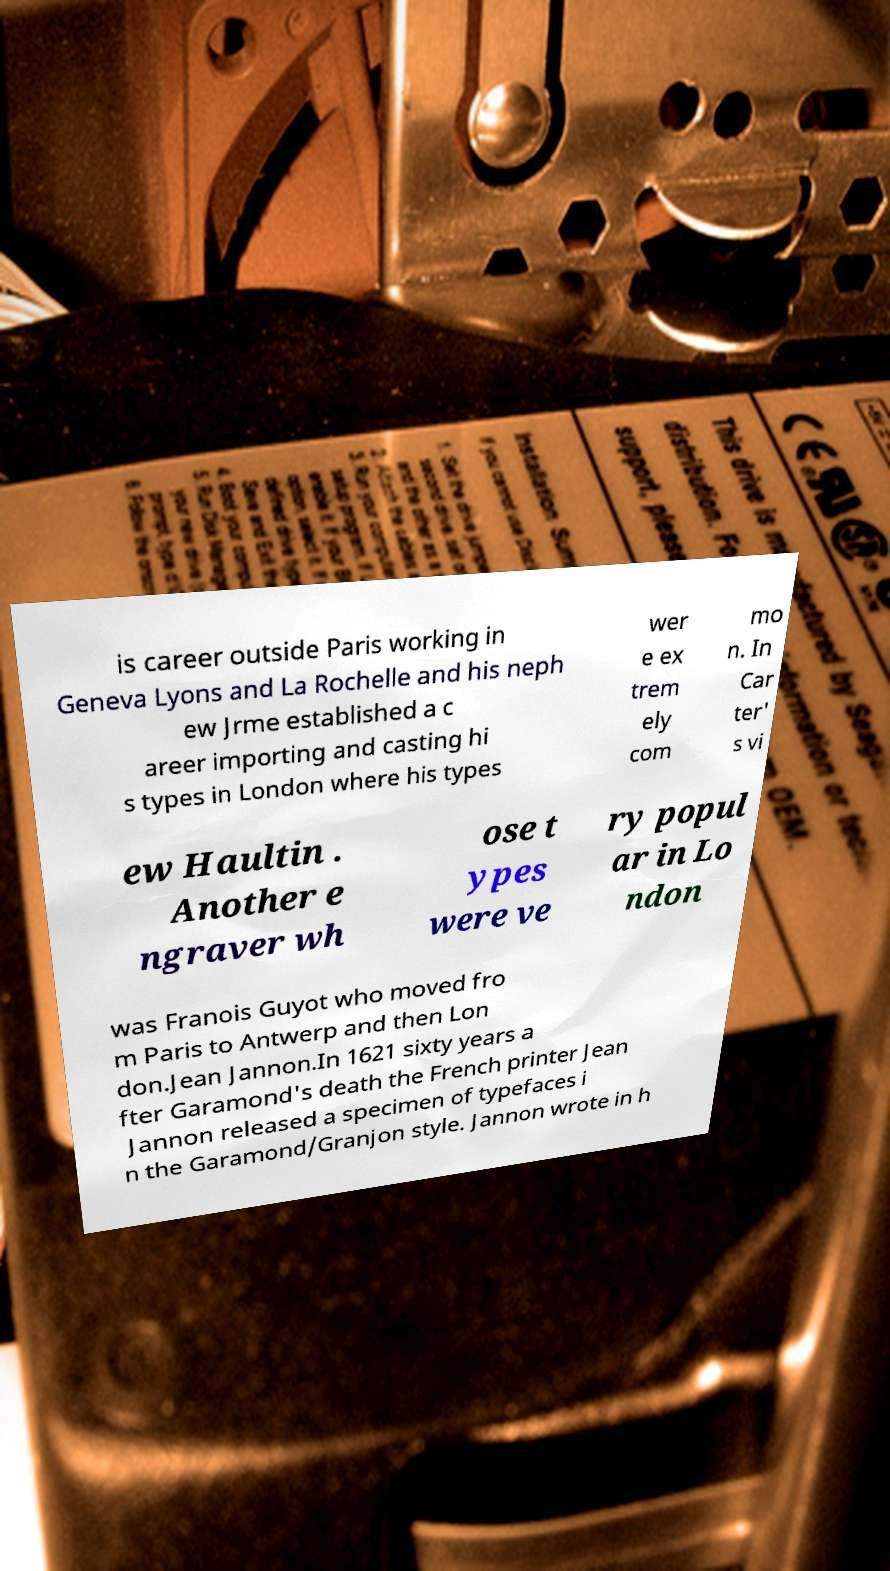For documentation purposes, I need the text within this image transcribed. Could you provide that? is career outside Paris working in Geneva Lyons and La Rochelle and his neph ew Jrme established a c areer importing and casting hi s types in London where his types wer e ex trem ely com mo n. In Car ter' s vi ew Haultin . Another e ngraver wh ose t ypes were ve ry popul ar in Lo ndon was Franois Guyot who moved fro m Paris to Antwerp and then Lon don.Jean Jannon.In 1621 sixty years a fter Garamond's death the French printer Jean Jannon released a specimen of typefaces i n the Garamond/Granjon style. Jannon wrote in h 